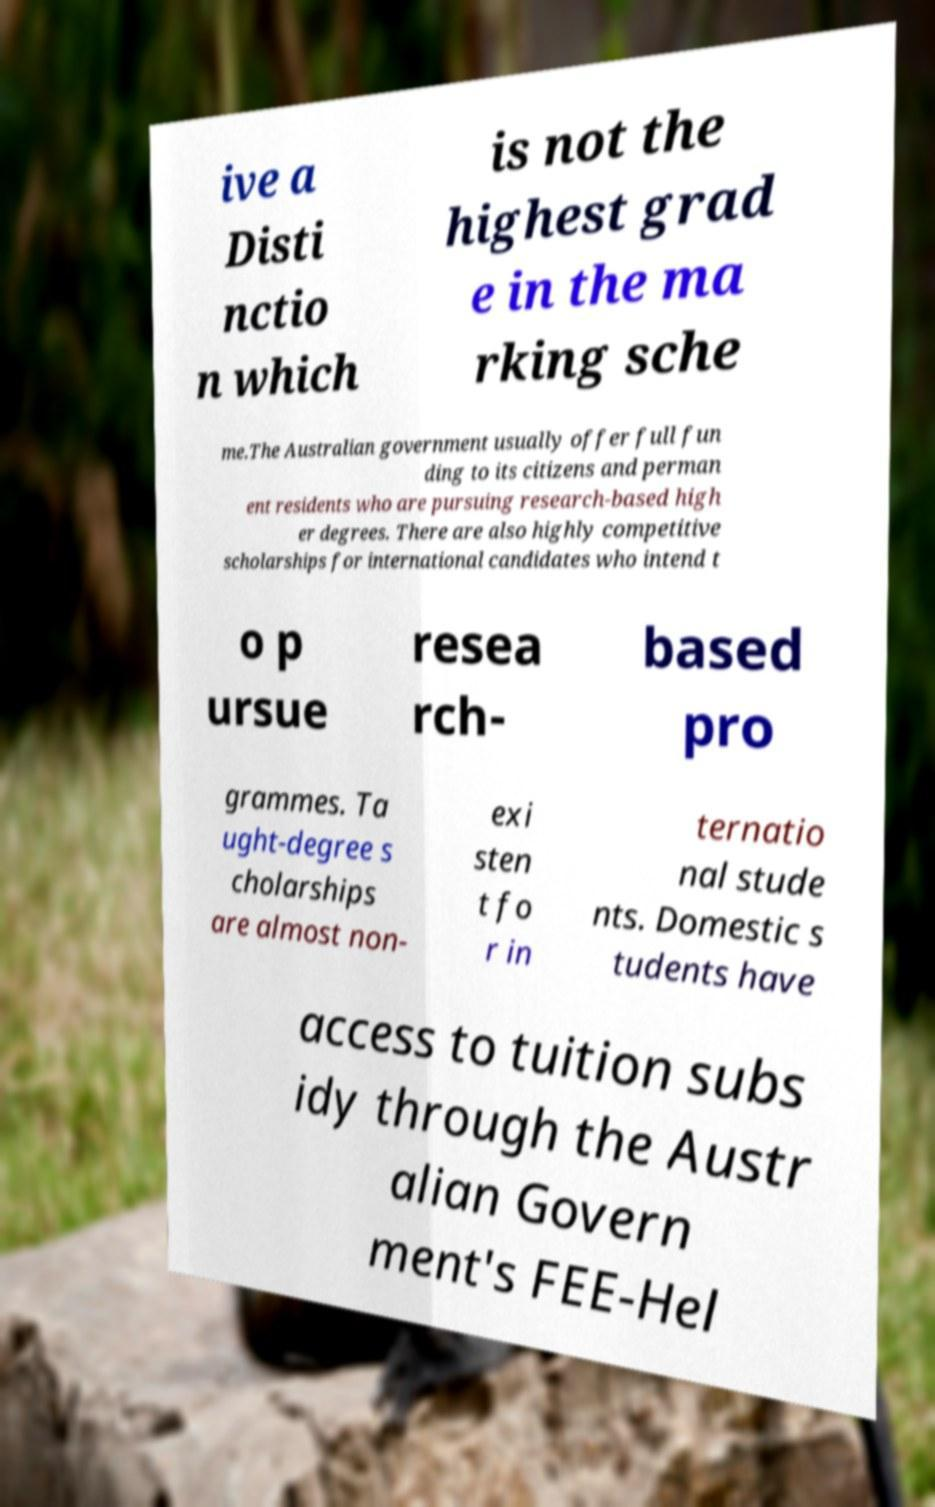Please read and relay the text visible in this image. What does it say? ive a Disti nctio n which is not the highest grad e in the ma rking sche me.The Australian government usually offer full fun ding to its citizens and perman ent residents who are pursuing research-based high er degrees. There are also highly competitive scholarships for international candidates who intend t o p ursue resea rch- based pro grammes. Ta ught-degree s cholarships are almost non- exi sten t fo r in ternatio nal stude nts. Domestic s tudents have access to tuition subs idy through the Austr alian Govern ment's FEE-Hel 